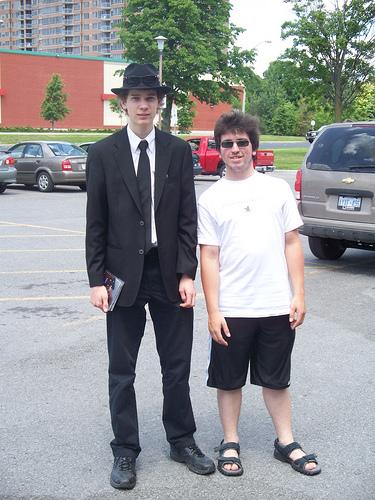Does anyone have a hat in the picture?
Answer briefly. Yes. What color is the shorter man's shirt?
Give a very brief answer. White. How many cars are there?
Answer briefly. 5. 